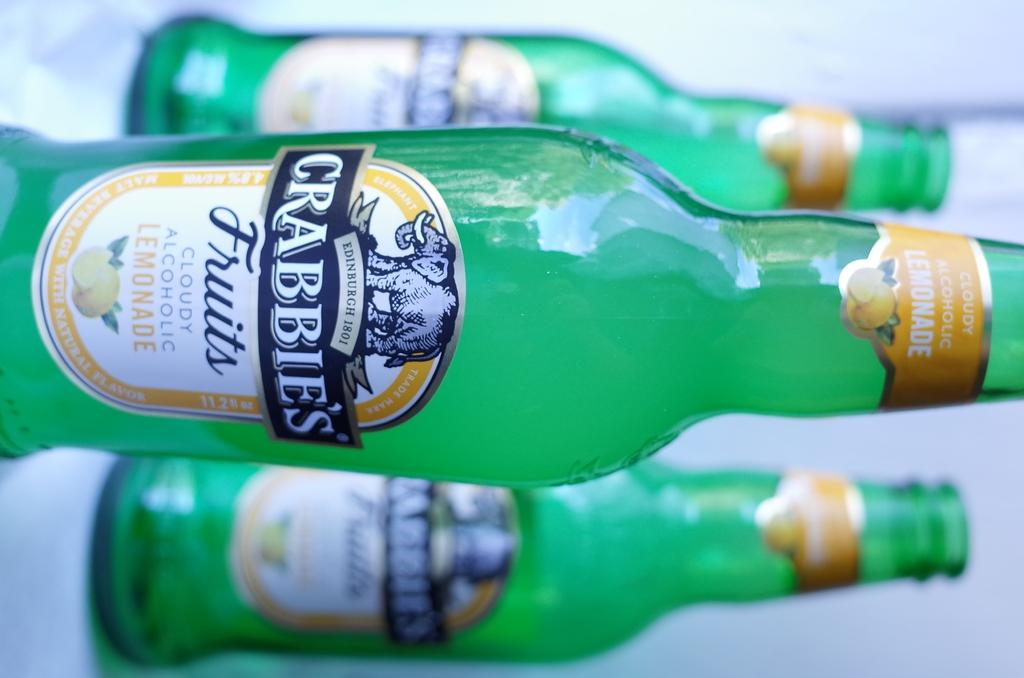<image>
Write a terse but informative summary of the picture. Three bottles of Crabbie's alcoholic lemonade are standing in a triangle. 